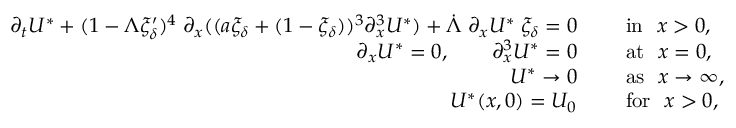<formula> <loc_0><loc_0><loc_500><loc_500>\begin{array} { r l } { \partial _ { t } U ^ { * } + ( 1 - \Lambda \xi _ { \delta } ^ { \prime } ) ^ { 4 } \, \partial _ { x } ( ( a \xi _ { \delta } + ( 1 - \xi _ { \delta } ) ) ^ { 3 } \partial _ { x } ^ { 3 } U ^ { * } ) + \dot { \Lambda } \, \partial _ { x } U ^ { * } \, \xi _ { \delta } = 0 \quad } & { i n \ x > 0 , } \\ { \partial _ { x } U ^ { * } = 0 , \quad \partial _ { x } ^ { 3 } U ^ { * } = 0 \quad } & { a t \ x = 0 , } \\ { U ^ { * } \to 0 \quad } & { a s \ x \to \infty , } \\ { U ^ { * } ( x , 0 ) = U _ { 0 } \quad } & { f o r \ x > 0 , } \end{array}</formula> 